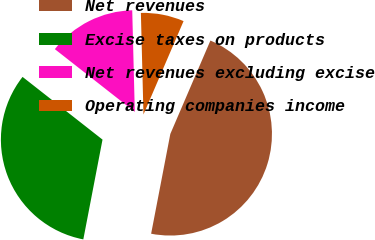Convert chart. <chart><loc_0><loc_0><loc_500><loc_500><pie_chart><fcel>Net revenues<fcel>Excise taxes on products<fcel>Net revenues excluding excise<fcel>Operating companies income<nl><fcel>46.57%<fcel>32.56%<fcel>14.01%<fcel>6.86%<nl></chart> 